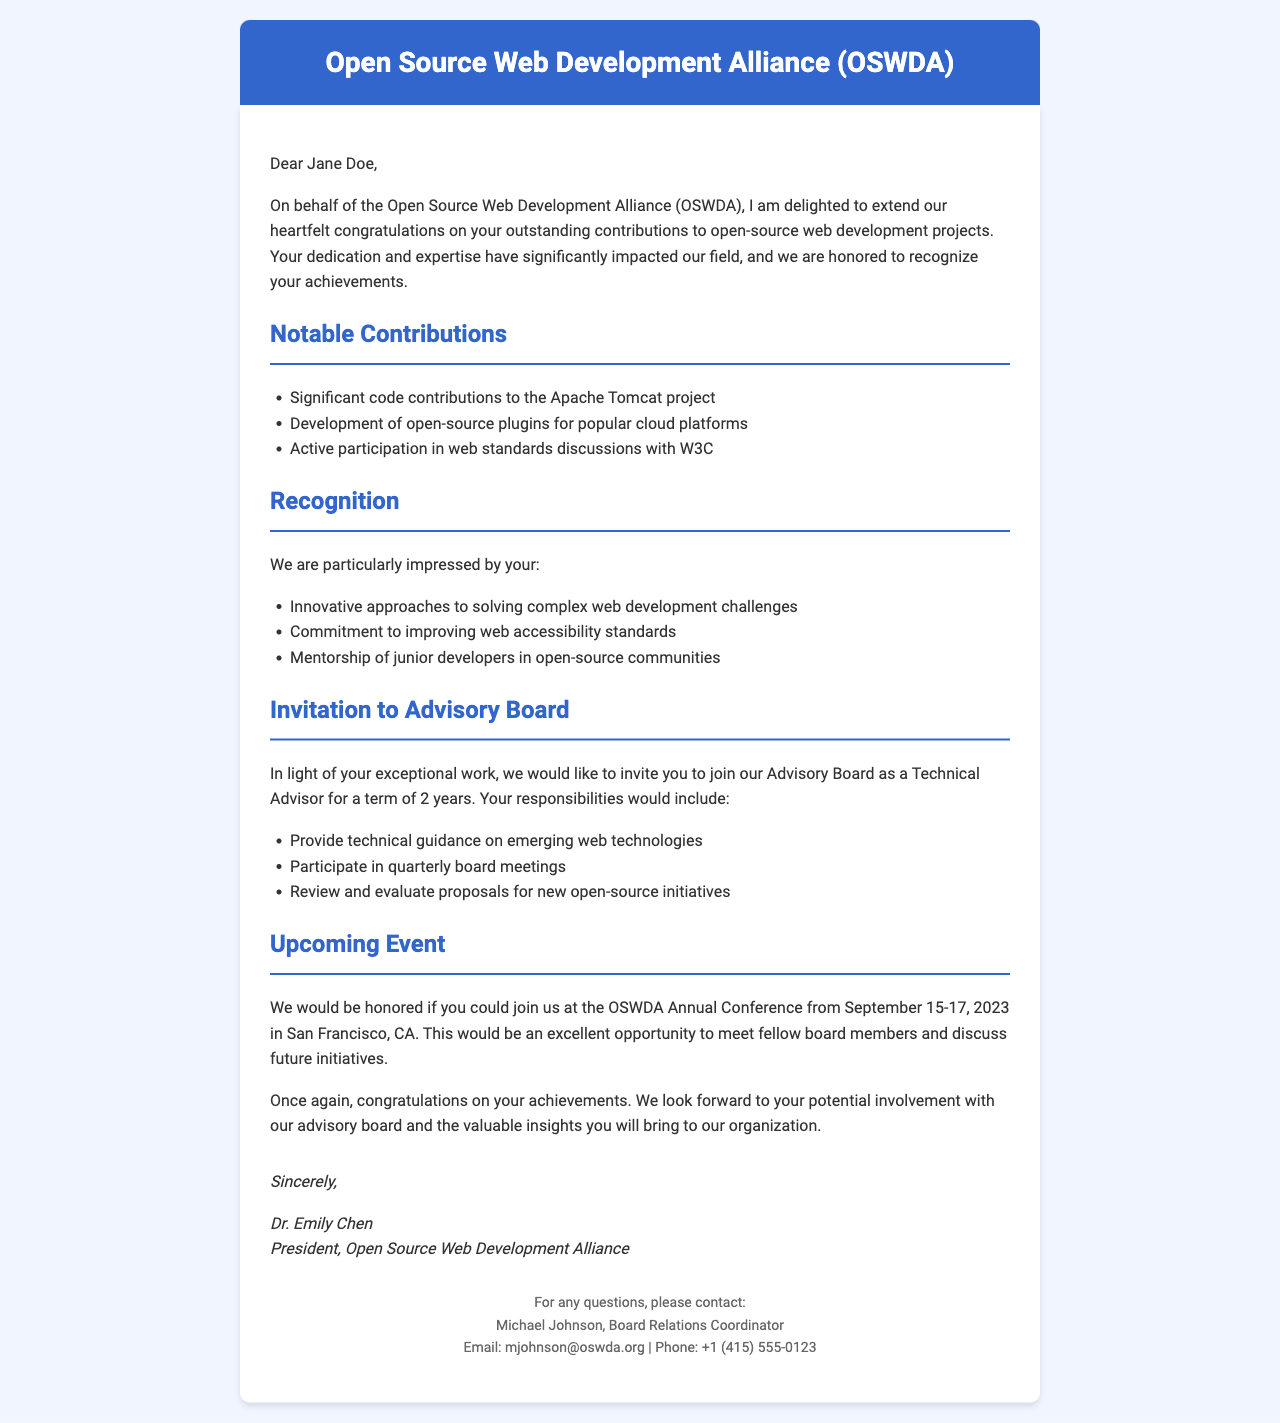What is the name of the association? The name of the association is mentioned at the beginning of the document.
Answer: Open Source Web Development Alliance (OSWDA) Who is the recipient of the letter? The recipient's name is stated at the opening of the letter.
Answer: Jane Doe What is Jane Doe's title? The title of the recipient is specified in the salutation.
Answer: Senior Software Engineer How many notable projects are listed? The number of notable projects is determined from the section dedicated to them.
Answer: 2 What is one of the notable projects mentioned? A notable project is outlined in the list of contributions.
Answer: CloudCanvas What role is being offered to Jane Doe? The specific role offered to the recipient is stated in the advisory board invitation.
Answer: Technical Advisor What is the term length for the advisory board position? The term length for the advisory board position is specified in the document.
Answer: 2 years When is the upcoming OSWDA Annual Conference? The date of the upcoming event is highlighted in the event section.
Answer: September 15-17, 2023 Who is the President of the association? The name of the president is provided at the end of the document.
Answer: Dr. Emily Chen 